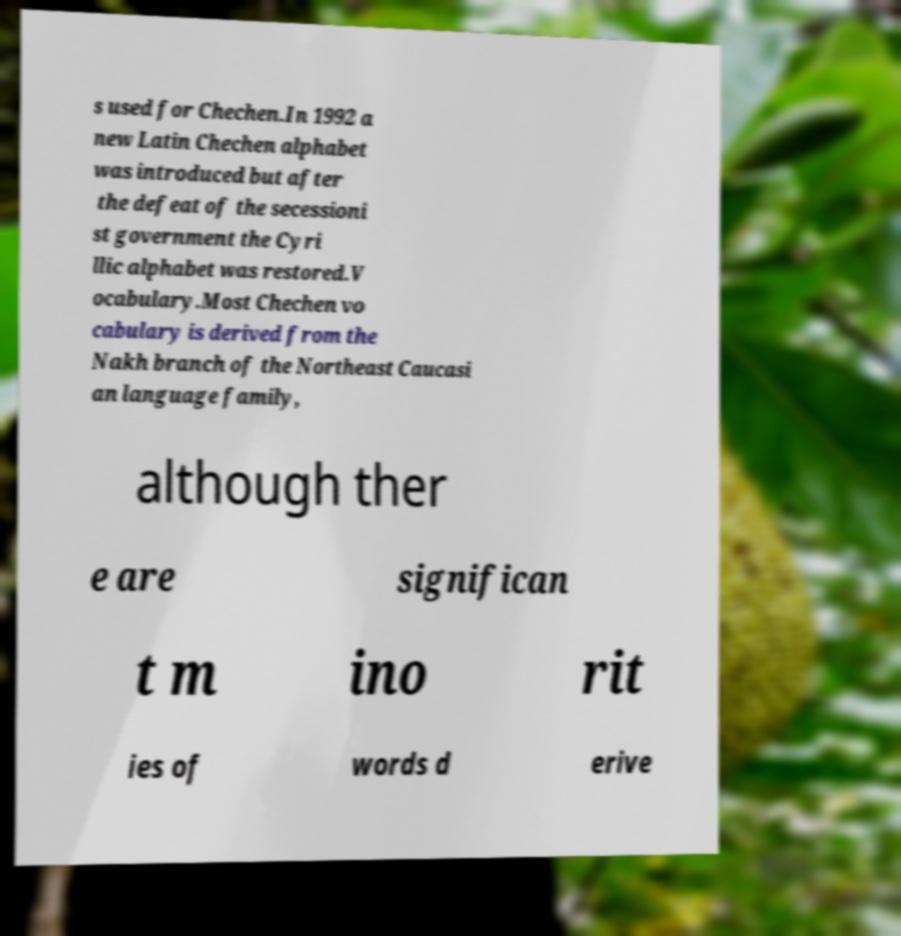Could you extract and type out the text from this image? s used for Chechen.In 1992 a new Latin Chechen alphabet was introduced but after the defeat of the secessioni st government the Cyri llic alphabet was restored.V ocabulary.Most Chechen vo cabulary is derived from the Nakh branch of the Northeast Caucasi an language family, although ther e are significan t m ino rit ies of words d erive 